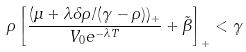<formula> <loc_0><loc_0><loc_500><loc_500>\rho \left [ \frac { ( \mu + \lambda \delta \rho / ( \gamma - \rho ) ) _ { + } } { V _ { 0 } e ^ { - \lambda T } } + \tilde { \beta } \right ] _ { + } < \gamma</formula> 